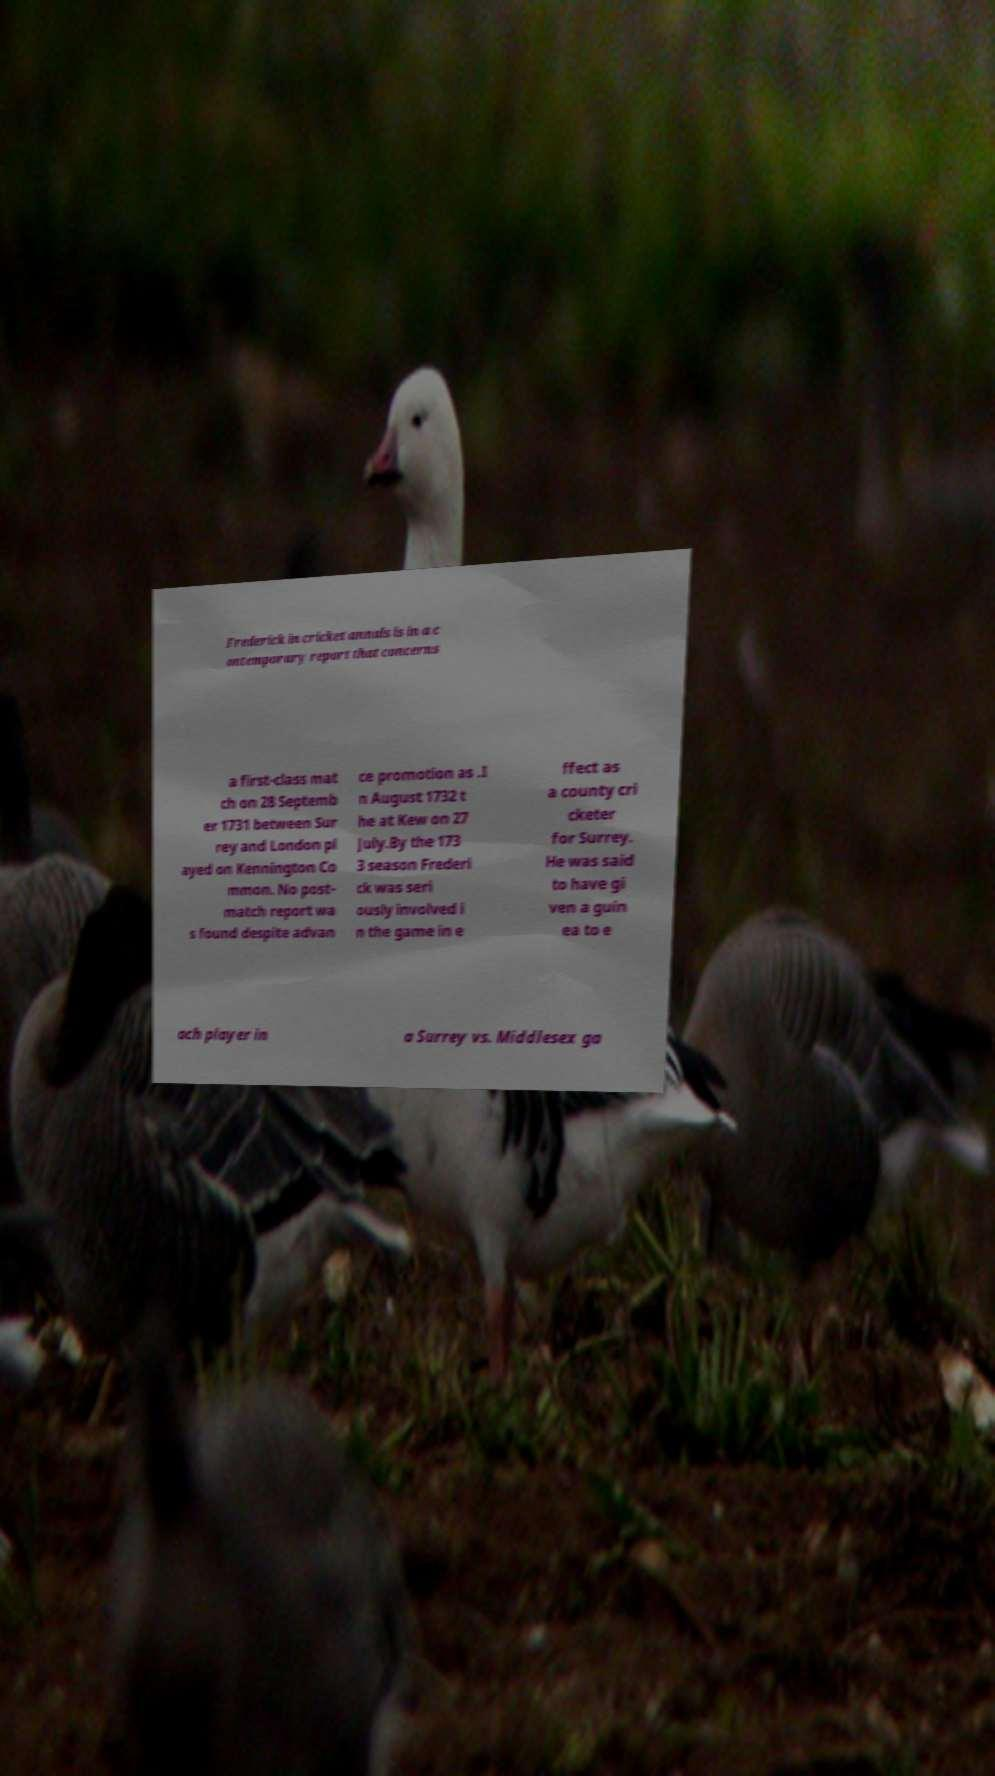Please read and relay the text visible in this image. What does it say? Frederick in cricket annals is in a c ontemporary report that concerns a first-class mat ch on 28 Septemb er 1731 between Sur rey and London pl ayed on Kennington Co mmon. No post- match report wa s found despite advan ce promotion as .I n August 1732 t he at Kew on 27 July.By the 173 3 season Frederi ck was seri ously involved i n the game in e ffect as a county cri cketer for Surrey. He was said to have gi ven a guin ea to e ach player in a Surrey vs. Middlesex ga 